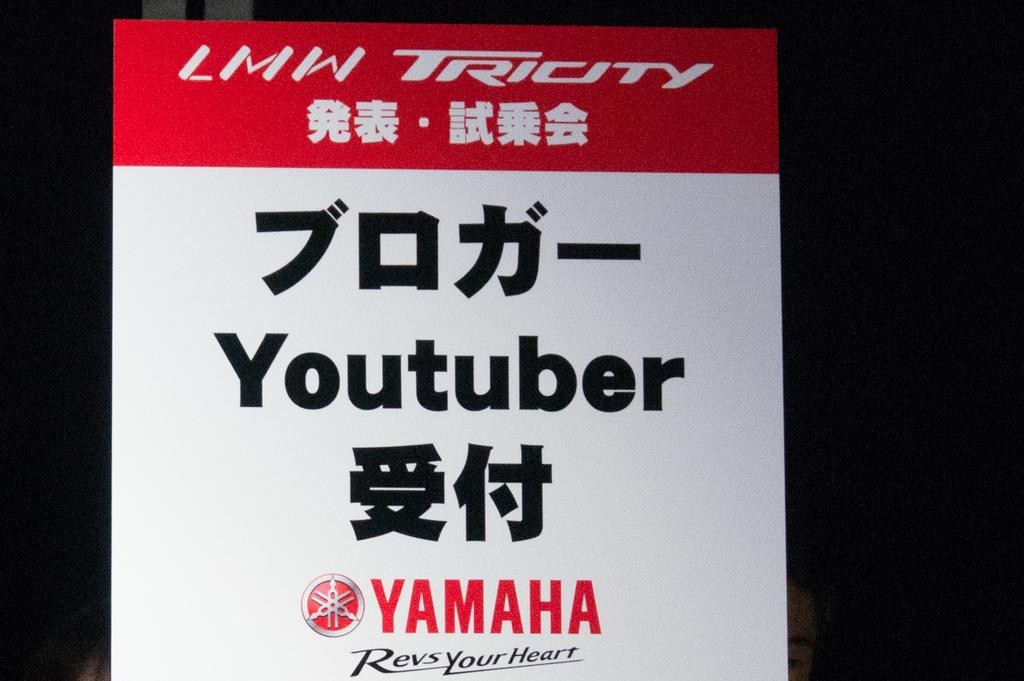What is the main object in the image? There is a red and white color board in the image. What can be seen on the color board? Something is written on the board. What color is the background of the image? The background of the image is black in color. How many frogs are sitting on the canvas in the image? There is no canvas or frogs present in the image. What are the boys doing in the image? There are no boys present in the image. 